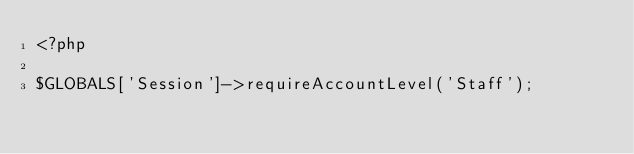<code> <loc_0><loc_0><loc_500><loc_500><_PHP_><?php

$GLOBALS['Session']->requireAccountLevel('Staff');
</code> 